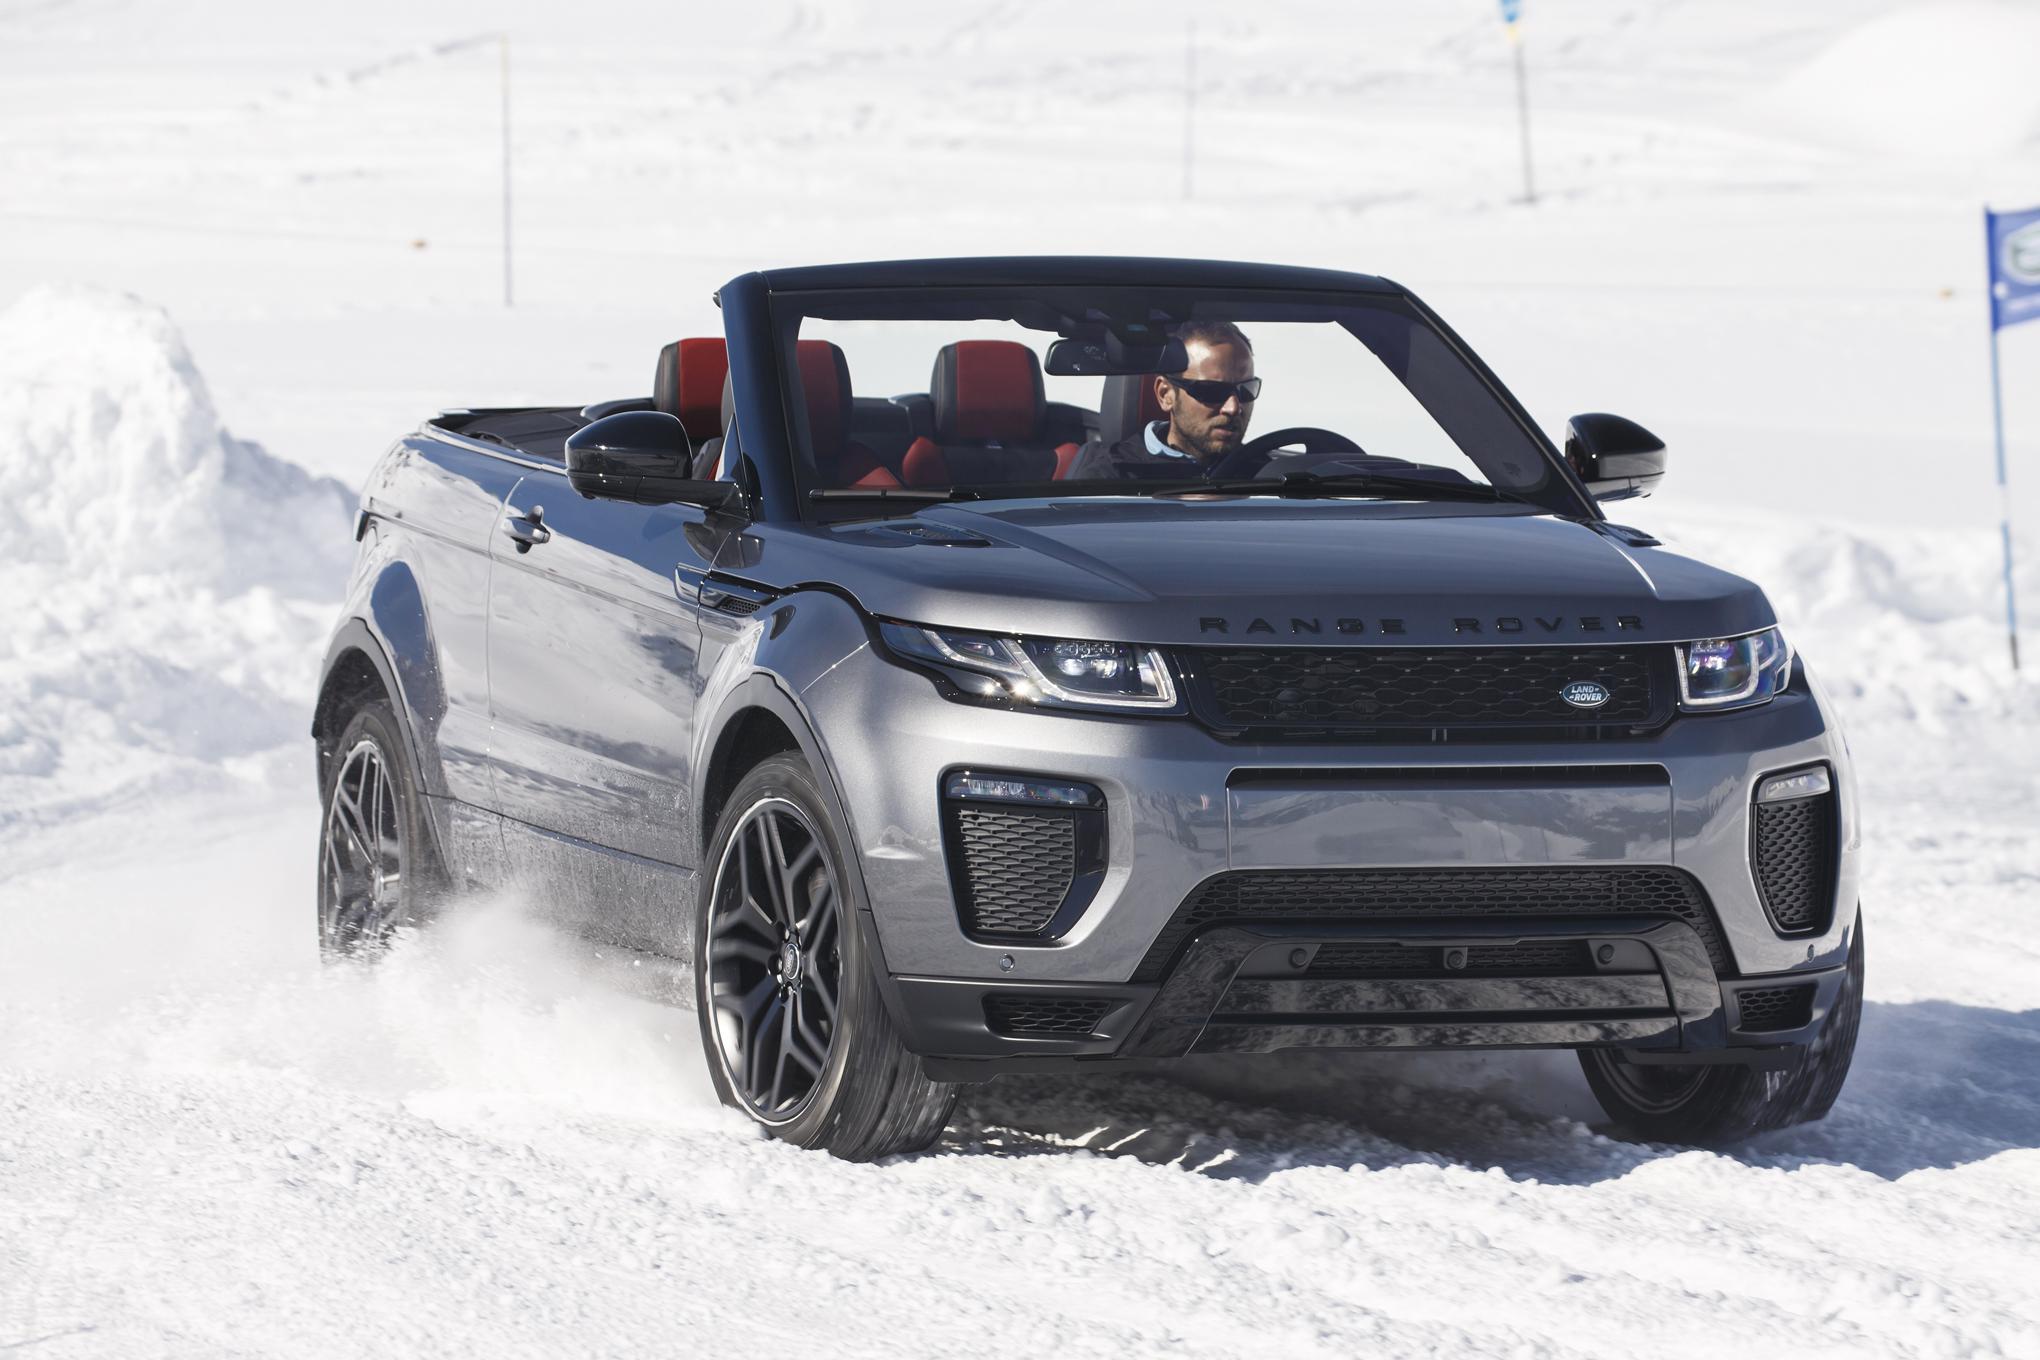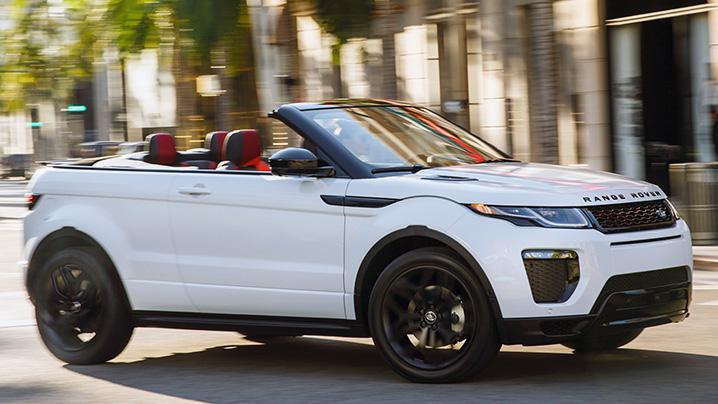The first image is the image on the left, the second image is the image on the right. Analyze the images presented: Is the assertion "The right image features one white topless convertible parked in a marked space facing the ocean, with its rear to the camera." valid? Answer yes or no. No. The first image is the image on the left, the second image is the image on the right. Examine the images to the left and right. Is the description "In one if the images, a car is facing the water and you can see its back licence plate." accurate? Answer yes or no. No. 